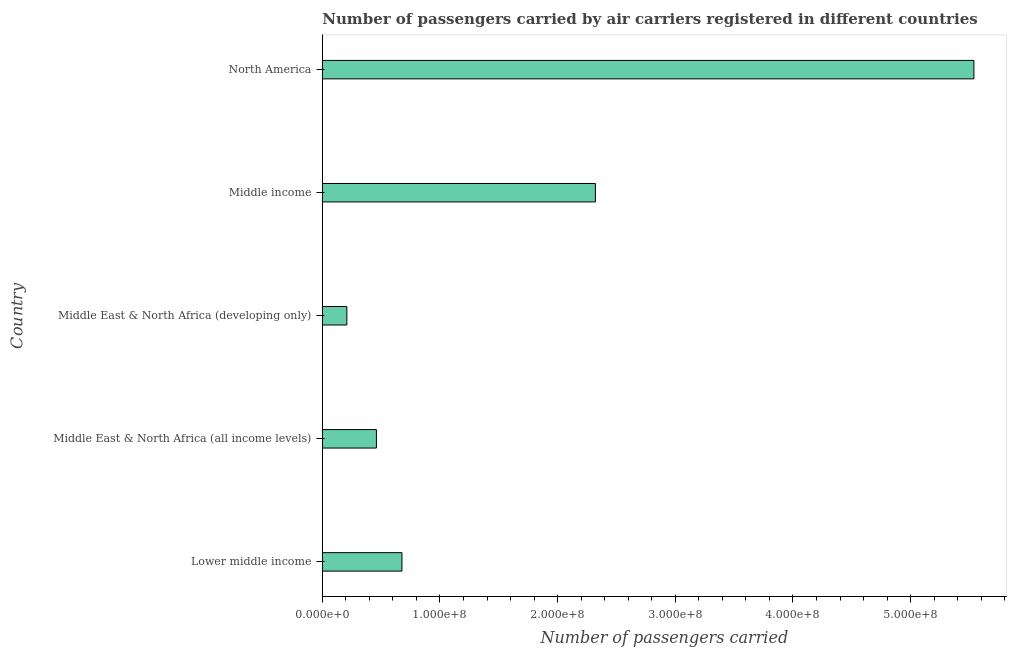Does the graph contain any zero values?
Your answer should be very brief. No. What is the title of the graph?
Offer a very short reply. Number of passengers carried by air carriers registered in different countries. What is the label or title of the X-axis?
Make the answer very short. Number of passengers carried. What is the number of passengers carried in Lower middle income?
Keep it short and to the point. 6.77e+07. Across all countries, what is the maximum number of passengers carried?
Give a very brief answer. 5.54e+08. Across all countries, what is the minimum number of passengers carried?
Your answer should be compact. 2.08e+07. In which country was the number of passengers carried minimum?
Offer a terse response. Middle East & North Africa (developing only). What is the sum of the number of passengers carried?
Your answer should be compact. 9.20e+08. What is the difference between the number of passengers carried in Lower middle income and Middle East & North Africa (all income levels)?
Ensure brevity in your answer.  2.17e+07. What is the average number of passengers carried per country?
Provide a short and direct response. 1.84e+08. What is the median number of passengers carried?
Provide a succinct answer. 6.77e+07. What is the ratio of the number of passengers carried in Middle East & North Africa (developing only) to that in Middle income?
Make the answer very short. 0.09. Is the number of passengers carried in Lower middle income less than that in Middle East & North Africa (developing only)?
Your answer should be compact. No. What is the difference between the highest and the second highest number of passengers carried?
Keep it short and to the point. 3.22e+08. What is the difference between the highest and the lowest number of passengers carried?
Provide a succinct answer. 5.33e+08. In how many countries, is the number of passengers carried greater than the average number of passengers carried taken over all countries?
Make the answer very short. 2. How many bars are there?
Your answer should be very brief. 5. Are all the bars in the graph horizontal?
Offer a very short reply. Yes. How many countries are there in the graph?
Provide a succinct answer. 5. What is the difference between two consecutive major ticks on the X-axis?
Offer a terse response. 1.00e+08. Are the values on the major ticks of X-axis written in scientific E-notation?
Make the answer very short. Yes. What is the Number of passengers carried in Lower middle income?
Ensure brevity in your answer.  6.77e+07. What is the Number of passengers carried in Middle East & North Africa (all income levels)?
Provide a short and direct response. 4.60e+07. What is the Number of passengers carried of Middle East & North Africa (developing only)?
Make the answer very short. 2.08e+07. What is the Number of passengers carried of Middle income?
Make the answer very short. 2.32e+08. What is the Number of passengers carried of North America?
Offer a terse response. 5.54e+08. What is the difference between the Number of passengers carried in Lower middle income and Middle East & North Africa (all income levels)?
Offer a terse response. 2.17e+07. What is the difference between the Number of passengers carried in Lower middle income and Middle East & North Africa (developing only)?
Offer a very short reply. 4.68e+07. What is the difference between the Number of passengers carried in Lower middle income and Middle income?
Keep it short and to the point. -1.64e+08. What is the difference between the Number of passengers carried in Lower middle income and North America?
Your answer should be compact. -4.86e+08. What is the difference between the Number of passengers carried in Middle East & North Africa (all income levels) and Middle East & North Africa (developing only)?
Offer a terse response. 2.51e+07. What is the difference between the Number of passengers carried in Middle East & North Africa (all income levels) and Middle income?
Make the answer very short. -1.86e+08. What is the difference between the Number of passengers carried in Middle East & North Africa (all income levels) and North America?
Offer a very short reply. -5.08e+08. What is the difference between the Number of passengers carried in Middle East & North Africa (developing only) and Middle income?
Your response must be concise. -2.11e+08. What is the difference between the Number of passengers carried in Middle East & North Africa (developing only) and North America?
Your answer should be very brief. -5.33e+08. What is the difference between the Number of passengers carried in Middle income and North America?
Your response must be concise. -3.22e+08. What is the ratio of the Number of passengers carried in Lower middle income to that in Middle East & North Africa (all income levels)?
Give a very brief answer. 1.47. What is the ratio of the Number of passengers carried in Lower middle income to that in Middle East & North Africa (developing only)?
Your answer should be very brief. 3.25. What is the ratio of the Number of passengers carried in Lower middle income to that in Middle income?
Give a very brief answer. 0.29. What is the ratio of the Number of passengers carried in Lower middle income to that in North America?
Your answer should be very brief. 0.12. What is the ratio of the Number of passengers carried in Middle East & North Africa (all income levels) to that in Middle East & North Africa (developing only)?
Ensure brevity in your answer.  2.21. What is the ratio of the Number of passengers carried in Middle East & North Africa (all income levels) to that in Middle income?
Provide a succinct answer. 0.2. What is the ratio of the Number of passengers carried in Middle East & North Africa (all income levels) to that in North America?
Offer a terse response. 0.08. What is the ratio of the Number of passengers carried in Middle East & North Africa (developing only) to that in Middle income?
Offer a very short reply. 0.09. What is the ratio of the Number of passengers carried in Middle East & North Africa (developing only) to that in North America?
Your answer should be compact. 0.04. What is the ratio of the Number of passengers carried in Middle income to that in North America?
Keep it short and to the point. 0.42. 